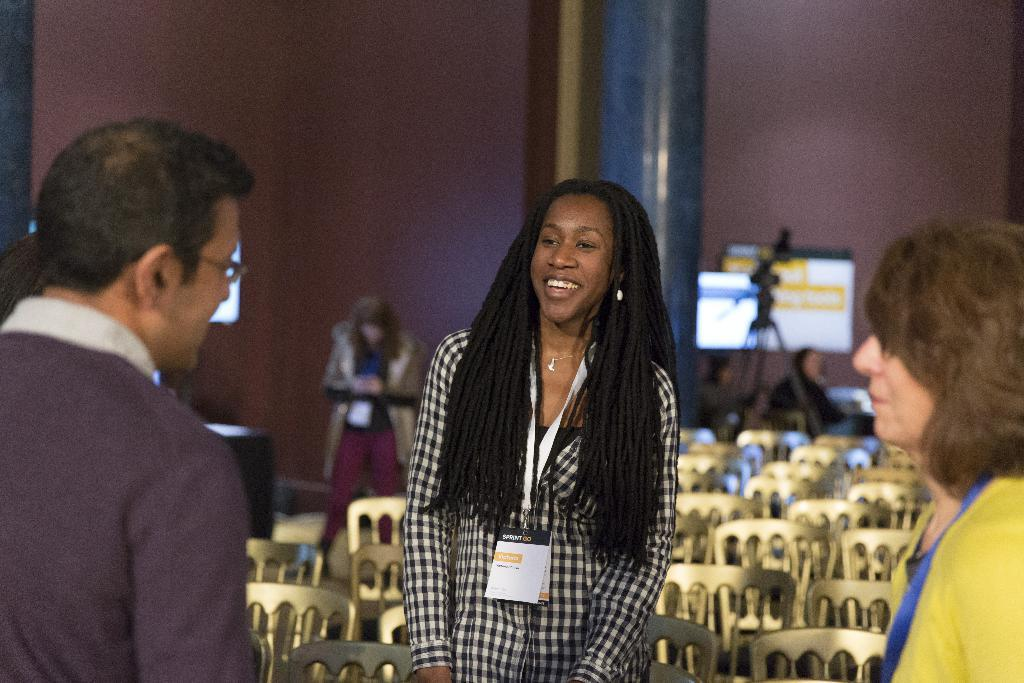How many people are standing in the image? There are three people standing in the image. Can you describe the woman in the image? The woman is wearing an ID card and smiling. What can be seen in the background of the image? There are chairs, a camera with a stand, a screen, people, and a pillar in the background of the image. What type of reaction can be seen from the bears in the image? There are no bears present in the image, so it is not possible to determine their reactions. 